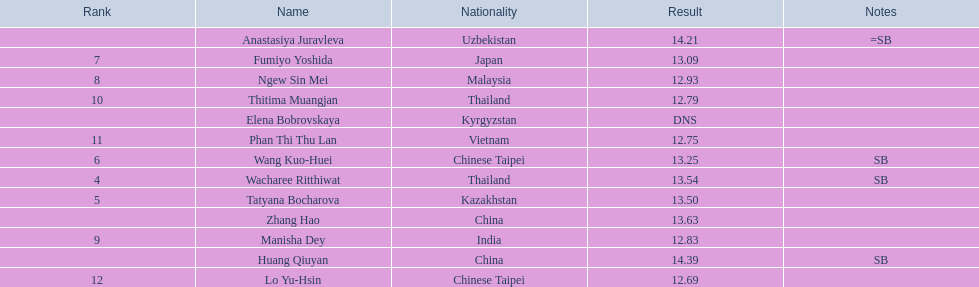How many athletes were from china? 2. Write the full table. {'header': ['Rank', 'Name', 'Nationality', 'Result', 'Notes'], 'rows': [['', 'Anastasiya Juravleva', 'Uzbekistan', '14.21', '=SB'], ['7', 'Fumiyo Yoshida', 'Japan', '13.09', ''], ['8', 'Ngew Sin Mei', 'Malaysia', '12.93', ''], ['10', 'Thitima Muangjan', 'Thailand', '12.79', ''], ['', 'Elena Bobrovskaya', 'Kyrgyzstan', 'DNS', ''], ['11', 'Phan Thi Thu Lan', 'Vietnam', '12.75', ''], ['6', 'Wang Kuo-Huei', 'Chinese Taipei', '13.25', 'SB'], ['4', 'Wacharee Ritthiwat', 'Thailand', '13.54', 'SB'], ['5', 'Tatyana Bocharova', 'Kazakhstan', '13.50', ''], ['', 'Zhang Hao', 'China', '13.63', ''], ['9', 'Manisha Dey', 'India', '12.83', ''], ['', 'Huang Qiuyan', 'China', '14.39', 'SB'], ['12', 'Lo Yu-Hsin', 'Chinese Taipei', '12.69', '']]} 